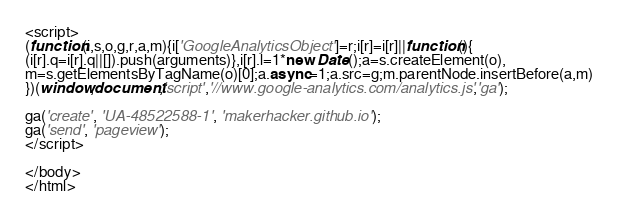Convert code to text. <code><loc_0><loc_0><loc_500><loc_500><_HTML_><script>
(function(i,s,o,g,r,a,m){i['GoogleAnalyticsObject']=r;i[r]=i[r]||function(){
(i[r].q=i[r].q||[]).push(arguments)},i[r].l=1*new Date();a=s.createElement(o),
m=s.getElementsByTagName(o)[0];a.async=1;a.src=g;m.parentNode.insertBefore(a,m)
})(window,document,'script','//www.google-analytics.com/analytics.js','ga');

ga('create', 'UA-48522588-1', 'makerhacker.github.io');
ga('send', 'pageview');
</script>

</body>
</html>
</code> 